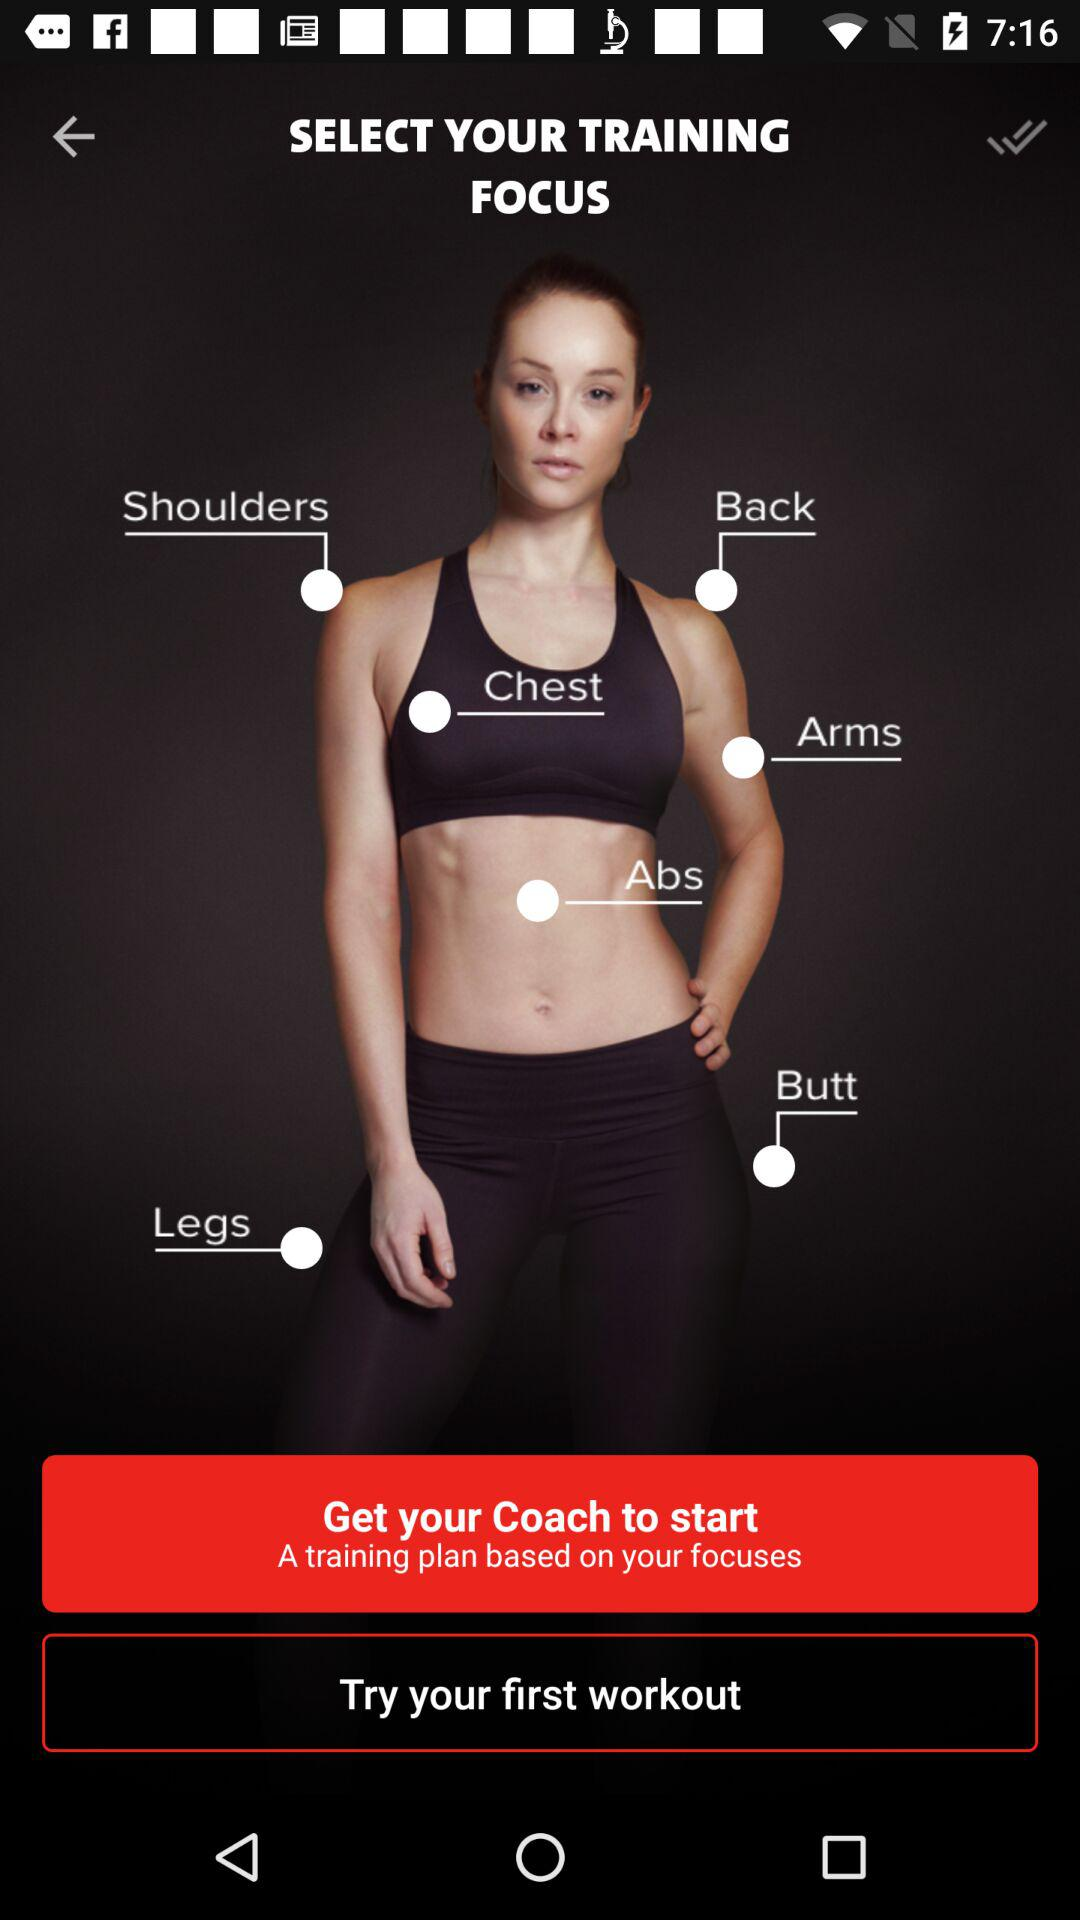How many training focuses are there?
Answer the question using a single word or phrase. 7 